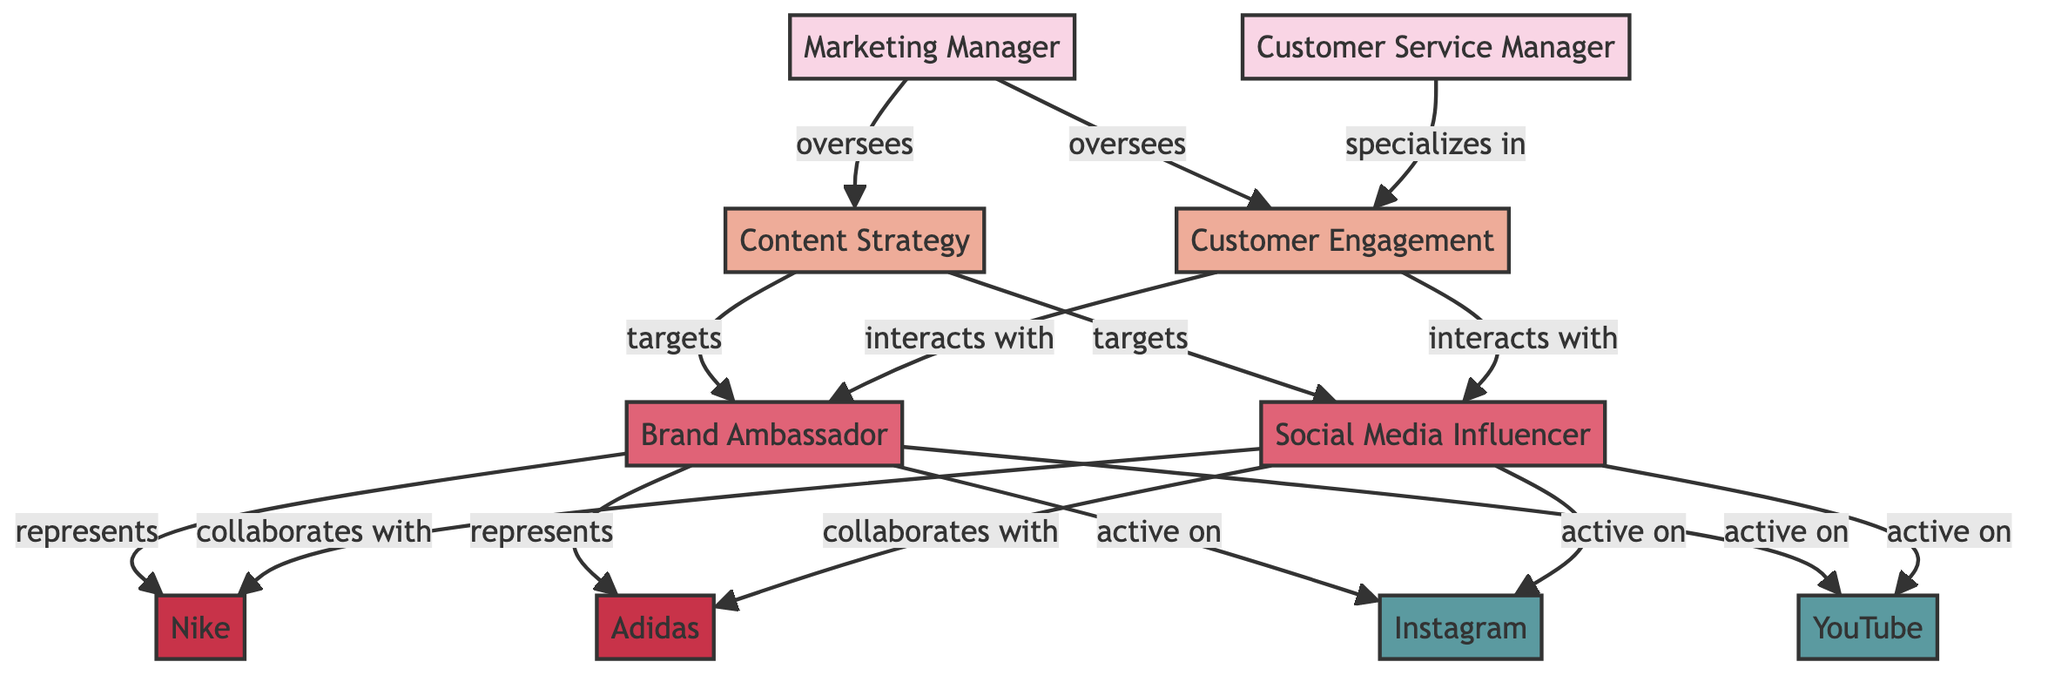What is the total number of nodes in the diagram? The diagram contains 10 nodes: Marketing Manager, Customer Service Manager, Content Strategy, Customer Engagement, Brand Ambassador, Social Media Influencer, Nike, Adidas, Instagram, and YouTube.
Answer: 10 Which role does the Customer Service Manager specialize in? The Customer Service Manager is connected to the Customer Engagement process with the label "specializes in". Therefore, their specialization is specifically within this process.
Answer: Customer Engagement How many brands are represented by the Brand Ambassador? The Brand Ambassador is connected to two brands: Nike and Adidas, as indicated by the edges labeled "represents."
Answer: 2 What type of connection exists between Content Strategy and Social Media Influencer? Content Strategy targets Social Media Influencer, as shown by the edge between these nodes with the label "targets," which signifies the aim to connect with this role.
Answer: targets Which platform do both the Brand Ambassador and Social Media Influencer actively use? Both the Brand Ambassador and Social Media Influencer have connections labeled "active on" to Instagram and YouTube. Therefore, both roles use these platforms actively.
Answer: Instagram, YouTube Which person oversees both the Content Strategy and Customer Engagement? The Marketing Manager is the person who oversees both the Content Strategy and Customer Engagement processes, as indicated by the edges connecting the Marketing Manager to these two nodes.
Answer: Marketing Manager How do Brand Ambassadors interact with Customer Engagement? The Brand Ambassador interacts with Customer Engagement, as shown by the edge labeled "interacts with" that connects these two nodes.
Answer: interacts with Which brands do both roles represent? Both the Brand Ambassador and Social Media Influencer represent Nike and also Adidas, as indicated by the edges labeled "represents" connecting both roles to these brands.
Answer: Nike, Adidas 